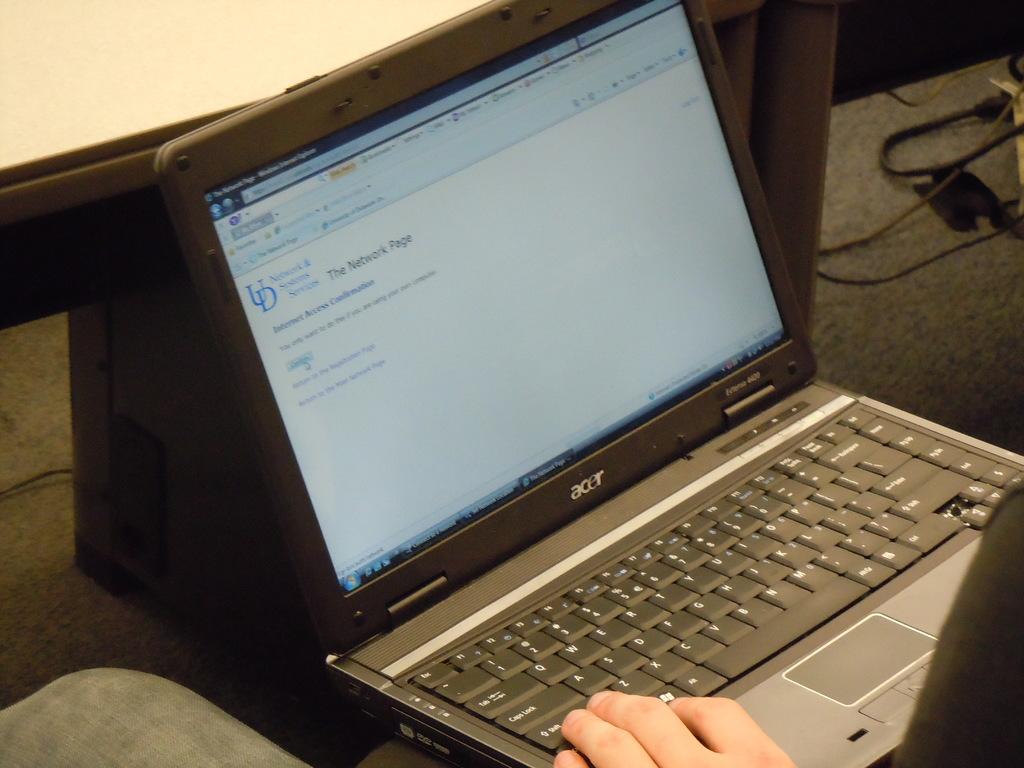What is the brand of the laptop?
Offer a very short reply. Acer. 